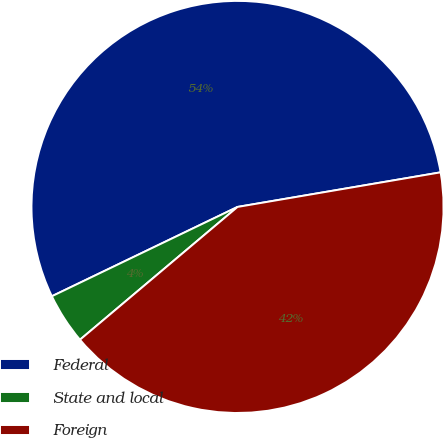Convert chart to OTSL. <chart><loc_0><loc_0><loc_500><loc_500><pie_chart><fcel>Federal<fcel>State and local<fcel>Foreign<nl><fcel>54.45%<fcel>4.01%<fcel>41.54%<nl></chart> 